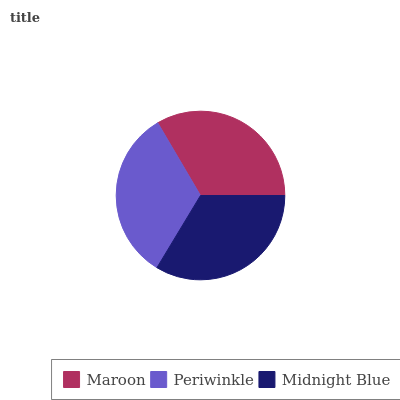Is Periwinkle the minimum?
Answer yes or no. Yes. Is Midnight Blue the maximum?
Answer yes or no. Yes. Is Midnight Blue the minimum?
Answer yes or no. No. Is Periwinkle the maximum?
Answer yes or no. No. Is Midnight Blue greater than Periwinkle?
Answer yes or no. Yes. Is Periwinkle less than Midnight Blue?
Answer yes or no. Yes. Is Periwinkle greater than Midnight Blue?
Answer yes or no. No. Is Midnight Blue less than Periwinkle?
Answer yes or no. No. Is Maroon the high median?
Answer yes or no. Yes. Is Maroon the low median?
Answer yes or no. Yes. Is Midnight Blue the high median?
Answer yes or no. No. Is Midnight Blue the low median?
Answer yes or no. No. 